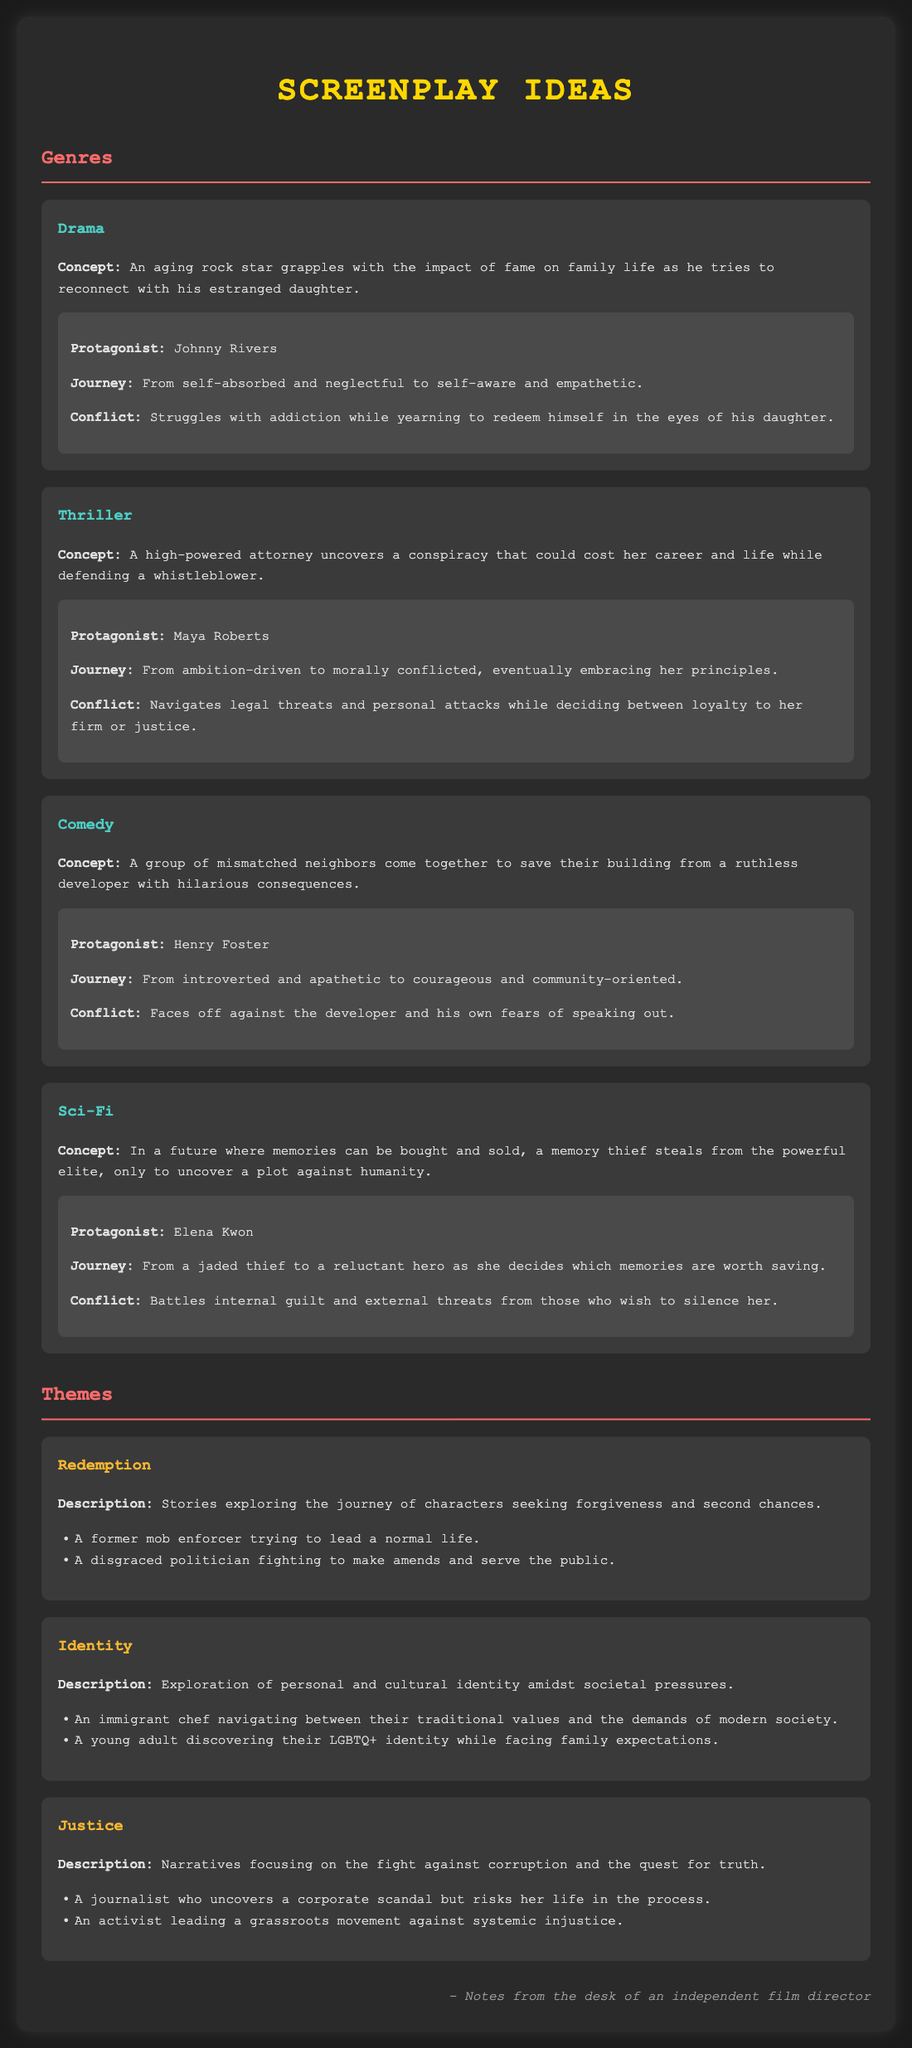What is the protagonist's name in the drama? The drama features an aging rock star named Johnny Rivers as the protagonist.
Answer: Johnny Rivers What is the journey of Maya Roberts in the thriller? Maya Roberts transforms from ambition-driven to morally conflicted as her character arc progresses throughout the story.
Answer: Morally conflicted What concept is presented in the comedy genre? The comedy presents a concept about neighbors banding together to save their building from a developer.
Answer: Save their building from a developer What theme involves characters seeking forgiveness and second chances? The theme that involves characters seeking forgiveness and second chances is known as Redemption.
Answer: Redemption How does Elena Kwon's journey change throughout the sci-fi narrative? Elena Kwon's journey evolves from a jaded thief to a reluctant hero who must decide which memories are worth saving.
Answer: Reluctant hero How many themes are presented in the document? The document outlines three distinct themes: Redemption, Identity, and Justice.
Answer: Three What conflict does Henry Foster face in the comedy? Henry Foster faces a conflict against the developer and his own fears of speaking out.
Answer: Developer and fears of speaking out Which character in the thriller embraces her principles? Maya Roberts, the protagonist in the thriller, ultimately embraces her principles amidst the conflicts she faces.
Answer: Maya Roberts What is the description of the Identity theme? The Identity theme explores personal and cultural identity amid societal pressures.
Answer: Personal and cultural identity amid societal pressures 